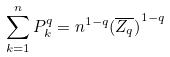Convert formula to latex. <formula><loc_0><loc_0><loc_500><loc_500>\sum _ { k = 1 } ^ { n } P _ { k } ^ { q } = n ^ { 1 - q } { ( \overline { Z _ { q } } ) } ^ { 1 - q }</formula> 